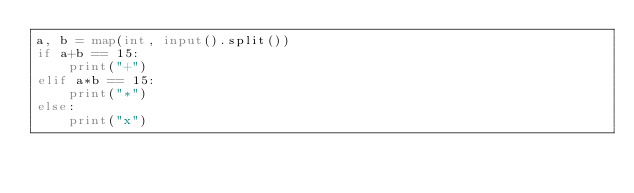<code> <loc_0><loc_0><loc_500><loc_500><_Python_>a, b = map(int, input().split())
if a+b == 15:
    print("+")
elif a*b == 15:
    print("*")
else:
    print("x")</code> 